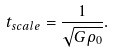<formula> <loc_0><loc_0><loc_500><loc_500>t _ { s c a l e } = \frac { 1 } { \sqrt { G \rho _ { 0 } } } .</formula> 